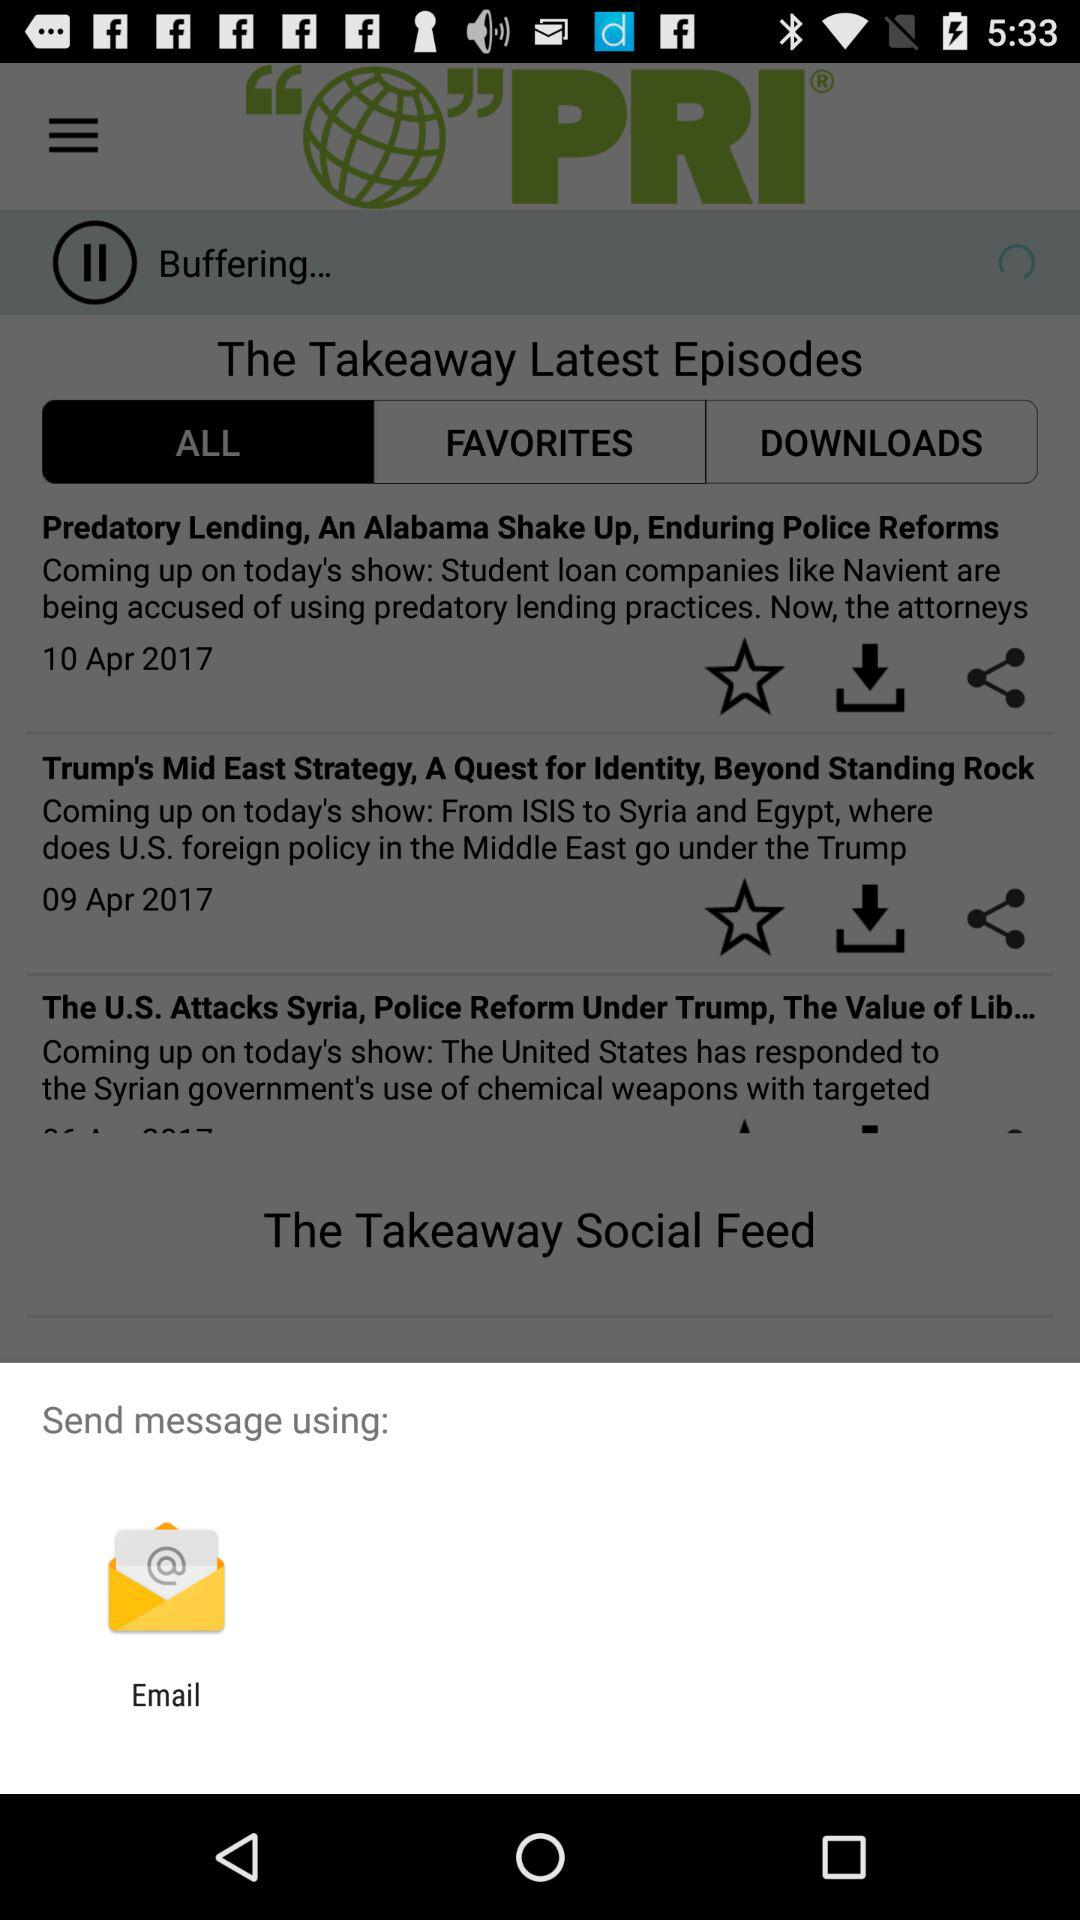How many episodes are featured in the Latest Episodes section?
Answer the question using a single word or phrase. 3 